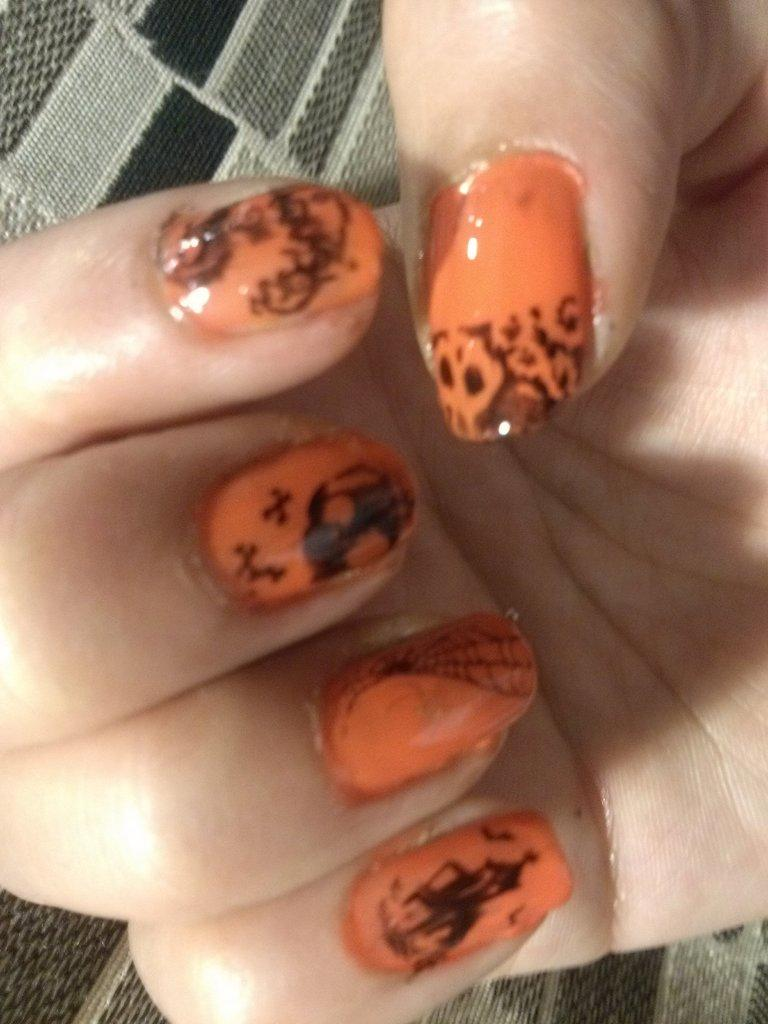What is the main subject of the image? The main subject of the image is the hand of a person. What can be observed about the nails on the hand? The nails on the hand have orange and black colors. What type of argument is the person having with the knife in the image? There is no argument or knife present in the image; it only features the hand of a person with colored nails. 